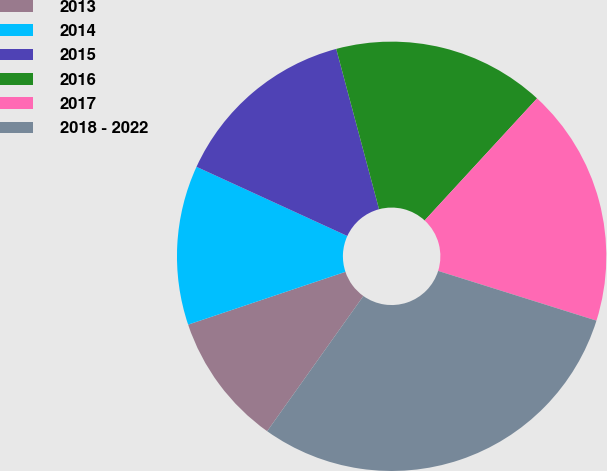<chart> <loc_0><loc_0><loc_500><loc_500><pie_chart><fcel>2013<fcel>2014<fcel>2015<fcel>2016<fcel>2017<fcel>2018 - 2022<nl><fcel>10.0%<fcel>12.0%<fcel>14.0%<fcel>16.0%<fcel>18.0%<fcel>30.0%<nl></chart> 